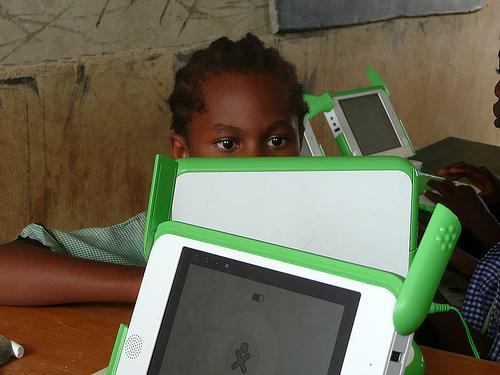How many toys are there?
Give a very brief answer. 2. How many people are in the photo?
Give a very brief answer. 1. 